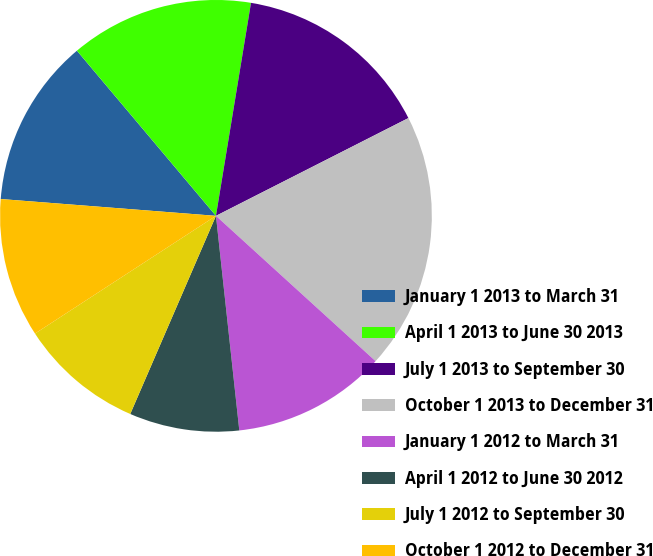Convert chart. <chart><loc_0><loc_0><loc_500><loc_500><pie_chart><fcel>January 1 2013 to March 31<fcel>April 1 2013 to June 30 2013<fcel>July 1 2013 to September 30<fcel>October 1 2013 to December 31<fcel>January 1 2012 to March 31<fcel>April 1 2012 to June 30 2012<fcel>July 1 2012 to September 30<fcel>October 1 2012 to December 31<nl><fcel>12.62%<fcel>13.73%<fcel>14.92%<fcel>19.23%<fcel>11.52%<fcel>8.22%<fcel>9.32%<fcel>10.42%<nl></chart> 